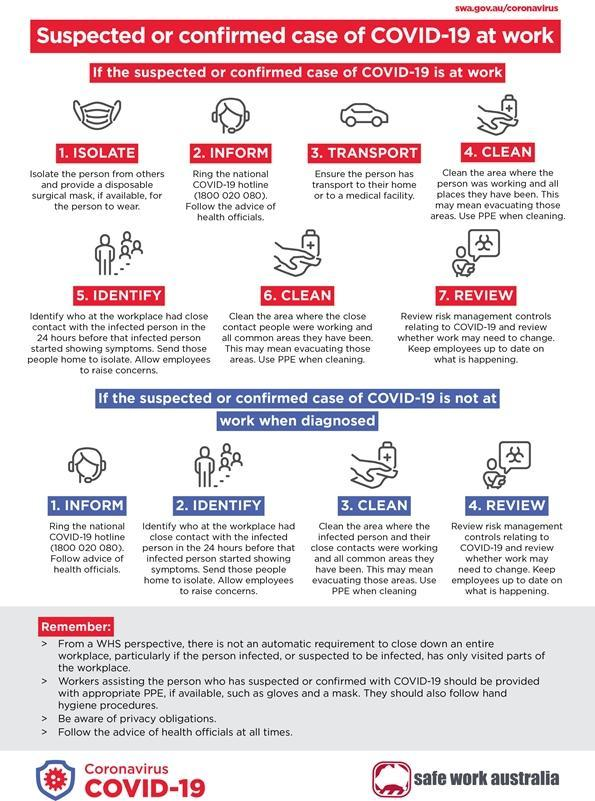providing a disposable surgical mask is a part of which step
Answer the question with a short phrase. Isolate how many points are common to do in suspected cases both at work at not at work 4 what are the main PPEs for workers assisting suspected or confirmed with COVID-19 gloves and mask 